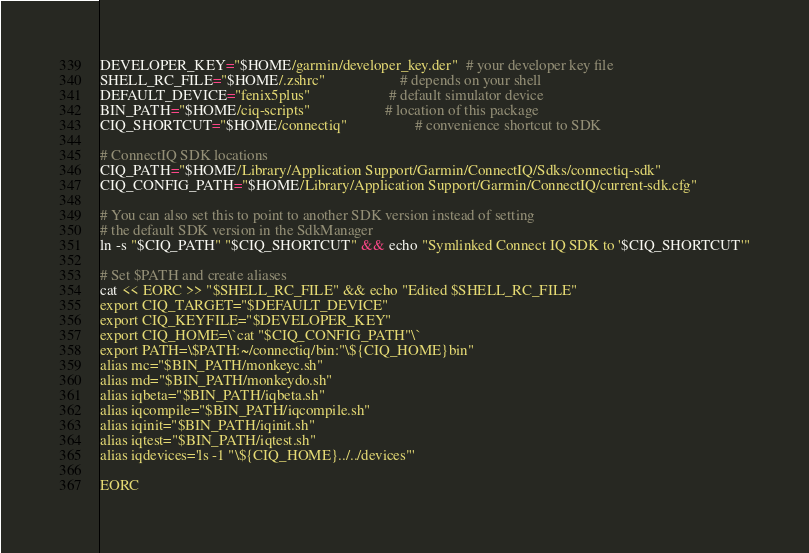<code> <loc_0><loc_0><loc_500><loc_500><_Bash_>DEVELOPER_KEY="$HOME/garmin/developer_key.der"  # your developer key file
SHELL_RC_FILE="$HOME/.zshrc"                    # depends on your shell
DEFAULT_DEVICE="fenix5plus"                     # default simulator device
BIN_PATH="$HOME/ciq-scripts"                    # location of this package
CIQ_SHORTCUT="$HOME/connectiq"                  # convenience shortcut to SDK

# ConnectIQ SDK locations
CIQ_PATH="$HOME/Library/Application Support/Garmin/ConnectIQ/Sdks/connectiq-sdk"
CIQ_CONFIG_PATH="$HOME/Library/Application Support/Garmin/ConnectIQ/current-sdk.cfg"

# You can also set this to point to another SDK version instead of setting
# the default SDK version in the SdkManager
ln -s "$CIQ_PATH" "$CIQ_SHORTCUT" && echo "Symlinked Connect IQ SDK to '$CIQ_SHORTCUT'"

# Set $PATH and create aliases
cat << EORC >> "$SHELL_RC_FILE" && echo "Edited $SHELL_RC_FILE"
export CIQ_TARGET="$DEFAULT_DEVICE"
export CIQ_KEYFILE="$DEVELOPER_KEY"
export CIQ_HOME=\`cat "$CIQ_CONFIG_PATH"\`
export PATH=\$PATH:~/connectiq/bin:"\${CIQ_HOME}bin"
alias mc="$BIN_PATH/monkeyc.sh"
alias md="$BIN_PATH/monkeydo.sh"
alias iqbeta="$BIN_PATH/iqbeta.sh"
alias iqcompile="$BIN_PATH/iqcompile.sh"
alias iqinit="$BIN_PATH/iqinit.sh"
alias iqtest="$BIN_PATH/iqtest.sh"
alias iqdevices='ls -1 "\${CIQ_HOME}../../devices"'

EORC
</code> 